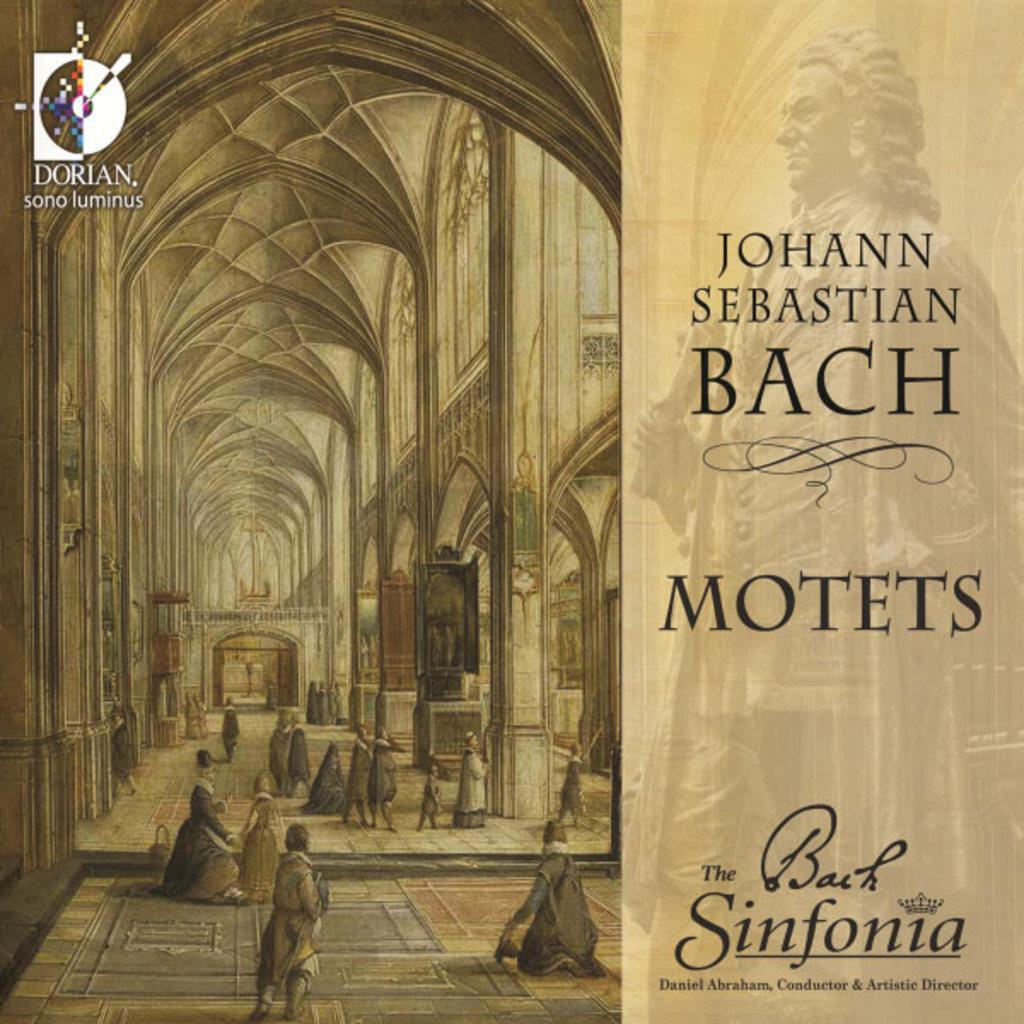Provide a one-sentence caption for the provided image. A album cover from Johan Sebastian Bach named Motots. 